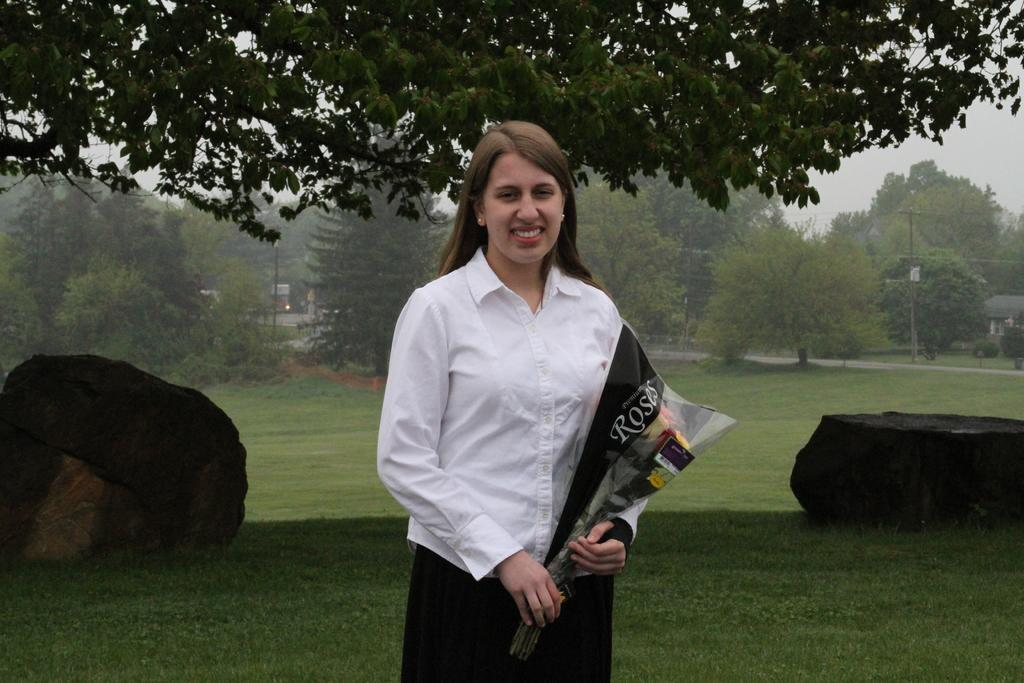Describe this image in one or two sentences. Background portion of the picture is blur. In the background we can see the trees, grass, rocks and few objects. We can see a woman wearing a white shirt, she is holding a flower bouquet and she is smiling. 